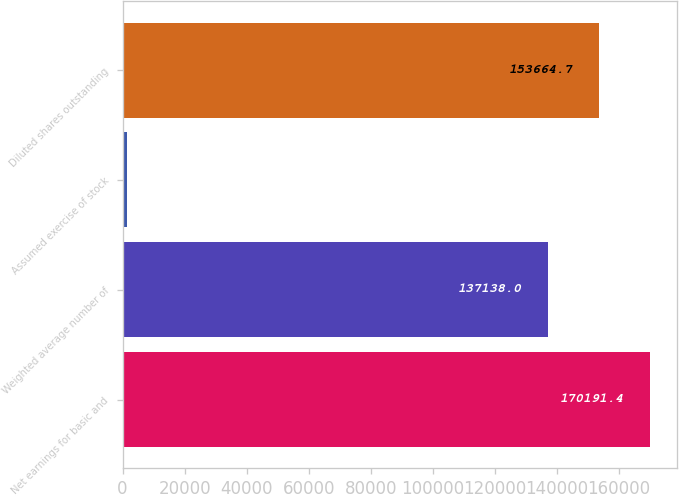Convert chart to OTSL. <chart><loc_0><loc_0><loc_500><loc_500><bar_chart><fcel>Net earnings for basic and<fcel>Weighted average number of<fcel>Assumed exercise of stock<fcel>Diluted shares outstanding<nl><fcel>170191<fcel>137138<fcel>1359<fcel>153665<nl></chart> 